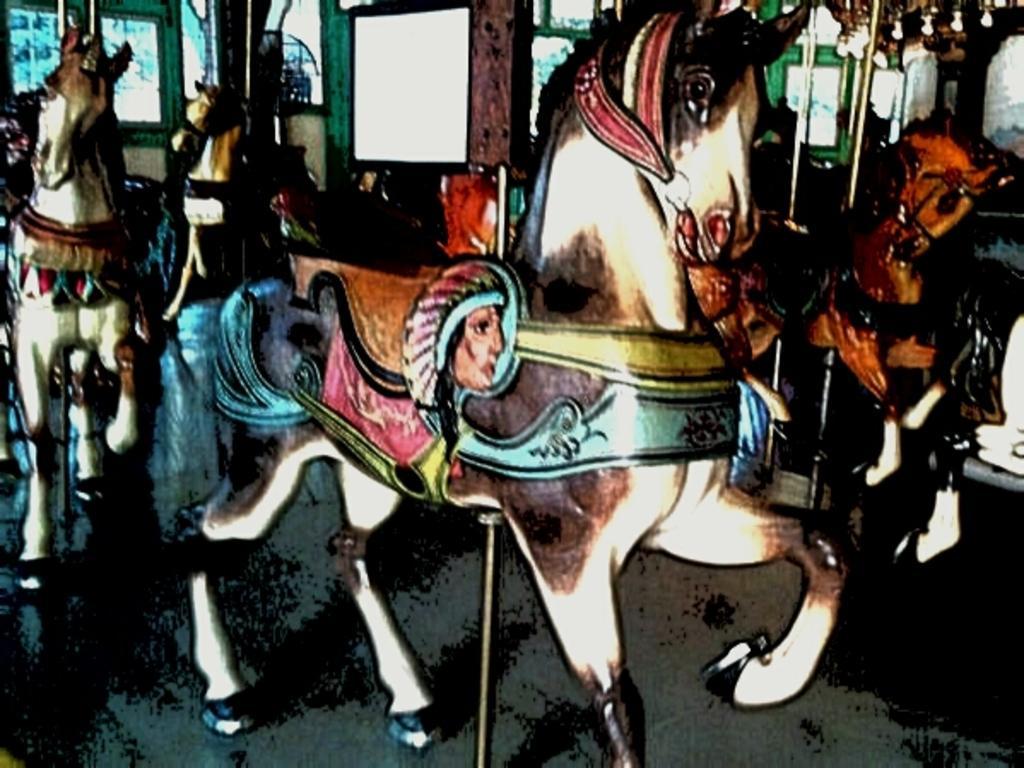Can you describe this image briefly? In this image there is a painting of the horses. 